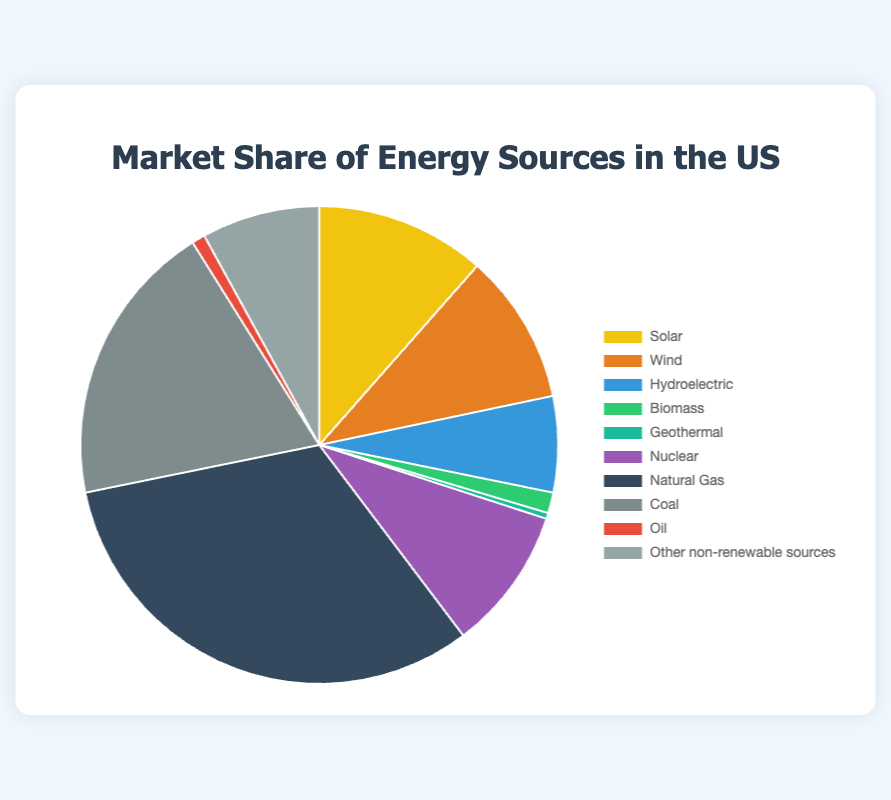Which energy source has the highest market share? The largest segment in the pie chart corresponds to the energy source "Natural Gas", which takes up the highest percentage of the market share.
Answer: Natural Gas What is the combined market share of Solar and Wind energy sources? The market share for Solar is 11.5% and for Wind is 10.2%. Adding them together gives 11.5 + 10.2 = 21.7%.
Answer: 21.7% Which has a greater market share: Coal or Nuclear energy? By comparing the segments, Coal has a market share of 19.3% while Nuclear has a market share of 9.7%. Therefore, Coal has a greater market share.
Answer: Coal What is the difference in market share between Hydroelectric and Biomass energy sources? Hydroelectric has a market share of 6.5% and Biomass has 1.4%. The difference is 6.5 - 1.4 = 5.1%.
Answer: 5.1% What's the total market share of all non-renewable energy sources? Adding the market shares of Natural Gas (32.1%), Coal (19.3%), Oil (0.9%), and Other non-renewable sources (8.0%), we get 32.1 + 19.3 + 0.9 + 8.0 = 60.3%.
Answer: 60.3% How does the market share of Solar compare to that of Nuclear energy? Solar has a market share of 11.5% while Nuclear has 9.7%. Comparing the two, Solar has a greater market share.
Answer: Solar Which energy source has the smallest market share? The smallest segment in the pie chart pertains to Geothermal energy, which has a market share of 0.4%.
Answer: Geothermal How does the combined market share of all renewable energy sources compare to that of Natural Gas? The combined market share of all renewable energy sources (Solar, Wind, Hydroelectric, Biomass, Geothermal) is 11.5 + 10.2 + 6.5 + 1.4 + 0.4 = 30%. The market share of Natural Gas is 32.1%. Thus, Natural Gas has a slightly higher market share.
Answer: Natural Gas What proportion of the market is covered by Wind energy relative to Coal? Wind energy has a market share of 10.2% and Coal 19.3%. The proportion of Wind to Coal is 10.2 / 19.3 ≈ 0.53.
Answer: 0.53 What is the visual color representation of the Hydroelectric energy segment? In the pie chart, the segment for Hydroelectric energy is represented by the color blue.
Answer: Blue 